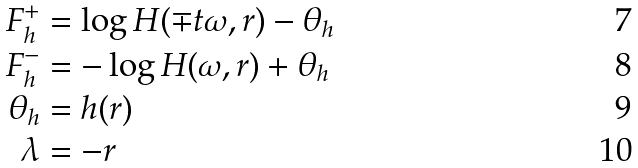Convert formula to latex. <formula><loc_0><loc_0><loc_500><loc_500>F _ { h } ^ { + } & = \log H ( \mp t \omega , r ) - \theta _ { h } \\ F _ { h } ^ { - } & = - \log H ( \omega , r ) + \theta _ { h } \\ \theta _ { h } & = h ( r ) \\ \lambda & = - r</formula> 